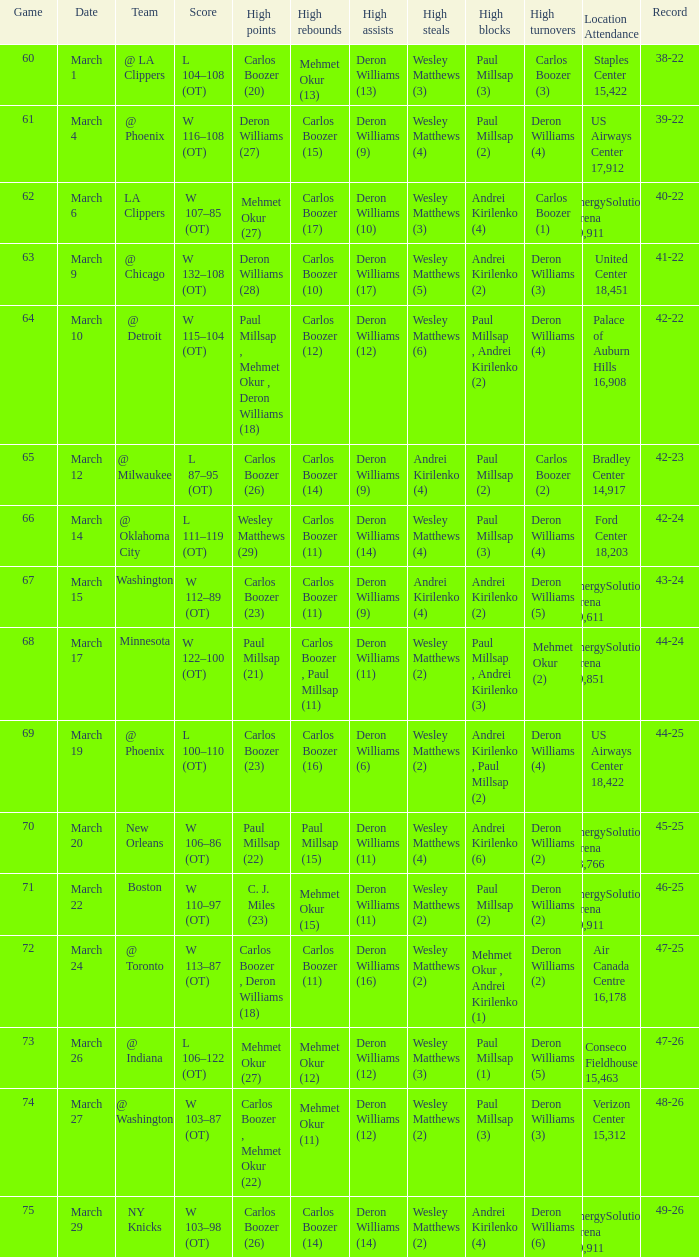Where was the March 24 game played? Air Canada Centre 16,178. 